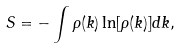<formula> <loc_0><loc_0><loc_500><loc_500>S = - \int \rho ( k ) \ln [ \rho ( k ) ] d k ,</formula> 